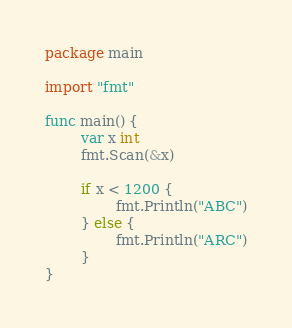Convert code to text. <code><loc_0><loc_0><loc_500><loc_500><_Go_>package main

import "fmt"

func main() {
        var x int
        fmt.Scan(&x)

        if x < 1200 {
                fmt.Println("ABC")
        } else {
                fmt.Println("ARC")
        }
}</code> 